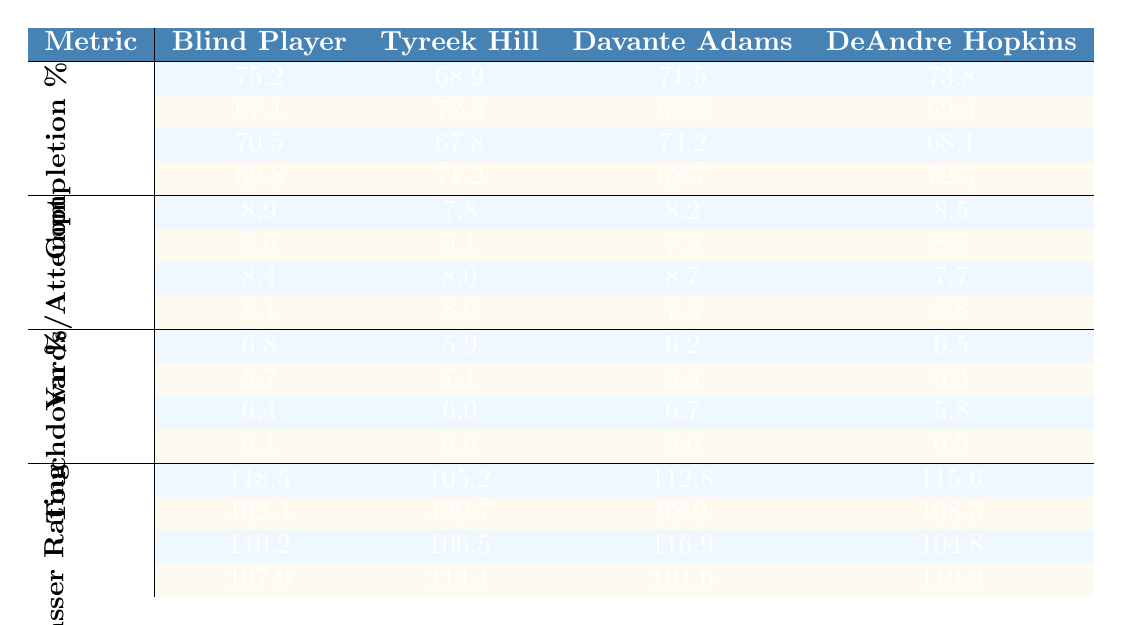What is the completion percentage for Tom Brady when paired with the Blind Player? From the table, the completion percentage for Tom Brady with the Blind Player is 75.2%.
Answer: 75.2% Which quarterback had the highest passer rating with Davante Adams? Looking at the passer rating column for Davante Adams, Aaron Rodgers has the highest passer rating at 116.9.
Answer: 116.9 What is the average yards per attempt for Patrick Mahomes across all receivers? For Patrick Mahomes, the yards per attempt values are 7.6 (Blind Player), 9.1 (Tyreek Hill), 7.9 (Davante Adams), and 8.3 (DeAndre Hopkins). The average is calculated as (7.6 + 9.1 + 7.9 + 8.3) / 4 = 8.225.
Answer: 8.23 Did any quarterback have a touchdown percentage over 7% when paired with Tyreek Hill? Checking the touchdown percentages for Tyreek Hill, the highest is 7.1% with Patrick Mahomes, which is over 7%. Thus, yes, there is a quarterback with a touchdown percentage over 7%.
Answer: Yes Which receiver consistently received the highest completion percentage from all quarterbacks? Analyzing the completion percentages for all receivers, the Blind Player has the highest values: 75.2, 67.1, 70.5, and 69.8, giving an average of 70.4, while the next highest is DeAndre Hopkins with an average of less than 70.4.
Answer: Blind Player What is the difference in yards per attempt between Russell Wilson and Aaron Rodgers when paired with DeAndre Hopkins? From the data, Russell Wilson has 8.8 yards per attempt and Aaron Rodgers has 7.7. The difference is 8.8 - 7.7 = 1.1.
Answer: 1.1 Which quarterback has the lowest touchdown percentage when throwing to Davante Adams? Looking at the touchdown percentages for Davante Adams, the lowest is 5.5% for Patrick Mahomes.
Answer: 5.5% What is the maximum passer rating achieved by any quarterback with the Blind Player? The table indicates that Tom Brady achieved a maximum passer rating of 118.5 with the Blind Player, which is the highest in that category.
Answer: 118.5 How do the completion percentages compare between the Blind Player and Tyreek Hill for Tom Brady? Tom Brady has 75.2% completion with the Blind Player and only 68.9% with Tyreek Hill. The Blind Player has a higher completion percentage by 6.3%.
Answer: Blind Player is higher Determine which combination of quarterback and receiver has the best touchdown percentage. From the data, the best touchdown percentage is 7.1% from Patrick Mahomes with Tyreek Hill, which is the highest across all combinations.
Answer: Patrick Mahomes and Tyreek Hill 